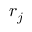Convert formula to latex. <formula><loc_0><loc_0><loc_500><loc_500>r _ { j }</formula> 